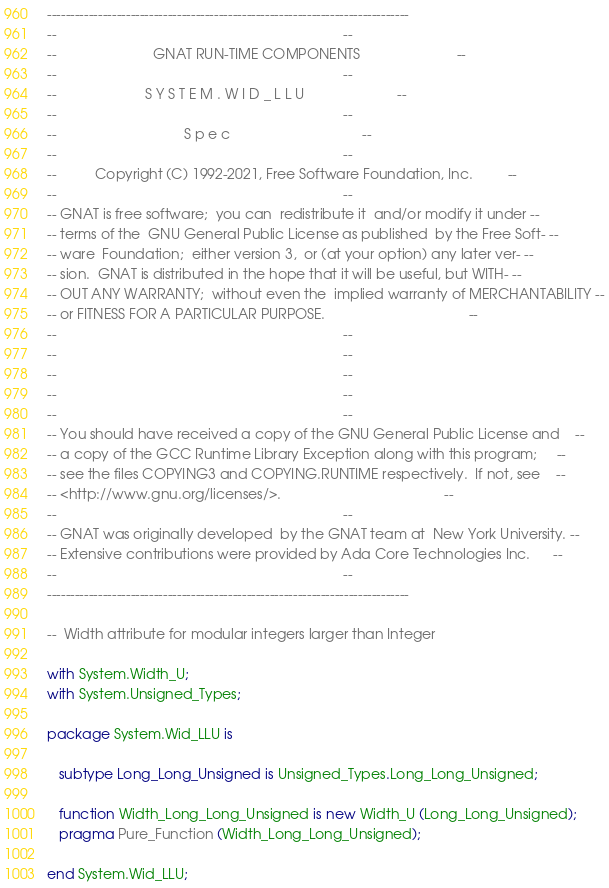<code> <loc_0><loc_0><loc_500><loc_500><_Ada_>------------------------------------------------------------------------------
--                                                                          --
--                         GNAT RUN-TIME COMPONENTS                         --
--                                                                          --
--                       S Y S T E M . W I D _ L L U                        --
--                                                                          --
--                                 S p e c                                  --
--                                                                          --
--          Copyright (C) 1992-2021, Free Software Foundation, Inc.         --
--                                                                          --
-- GNAT is free software;  you can  redistribute it  and/or modify it under --
-- terms of the  GNU General Public License as published  by the Free Soft- --
-- ware  Foundation;  either version 3,  or (at your option) any later ver- --
-- sion.  GNAT is distributed in the hope that it will be useful, but WITH- --
-- OUT ANY WARRANTY;  without even the  implied warranty of MERCHANTABILITY --
-- or FITNESS FOR A PARTICULAR PURPOSE.                                     --
--                                                                          --
--                                                                          --
--                                                                          --
--                                                                          --
--                                                                          --
-- You should have received a copy of the GNU General Public License and    --
-- a copy of the GCC Runtime Library Exception along with this program;     --
-- see the files COPYING3 and COPYING.RUNTIME respectively.  If not, see    --
-- <http://www.gnu.org/licenses/>.                                          --
--                                                                          --
-- GNAT was originally developed  by the GNAT team at  New York University. --
-- Extensive contributions were provided by Ada Core Technologies Inc.      --
--                                                                          --
------------------------------------------------------------------------------

--  Width attribute for modular integers larger than Integer

with System.Width_U;
with System.Unsigned_Types;

package System.Wid_LLU is

   subtype Long_Long_Unsigned is Unsigned_Types.Long_Long_Unsigned;

   function Width_Long_Long_Unsigned is new Width_U (Long_Long_Unsigned);
   pragma Pure_Function (Width_Long_Long_Unsigned);

end System.Wid_LLU;
</code> 